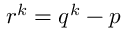<formula> <loc_0><loc_0><loc_500><loc_500>r ^ { k } = q ^ { k } - p</formula> 